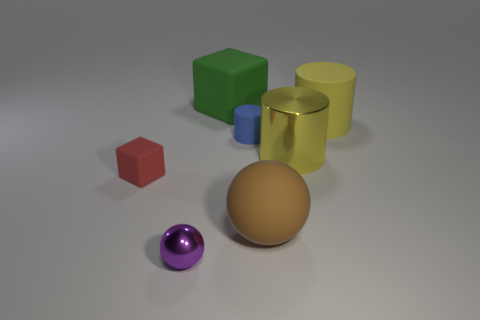Subtract all rubber cylinders. How many cylinders are left? 1 Add 1 red matte things. How many objects exist? 8 Subtract all blocks. How many objects are left? 5 Subtract 0 cyan cubes. How many objects are left? 7 Subtract all purple metallic cylinders. Subtract all small blue objects. How many objects are left? 6 Add 7 large brown rubber spheres. How many large brown rubber spheres are left? 8 Add 7 tiny purple cubes. How many tiny purple cubes exist? 7 